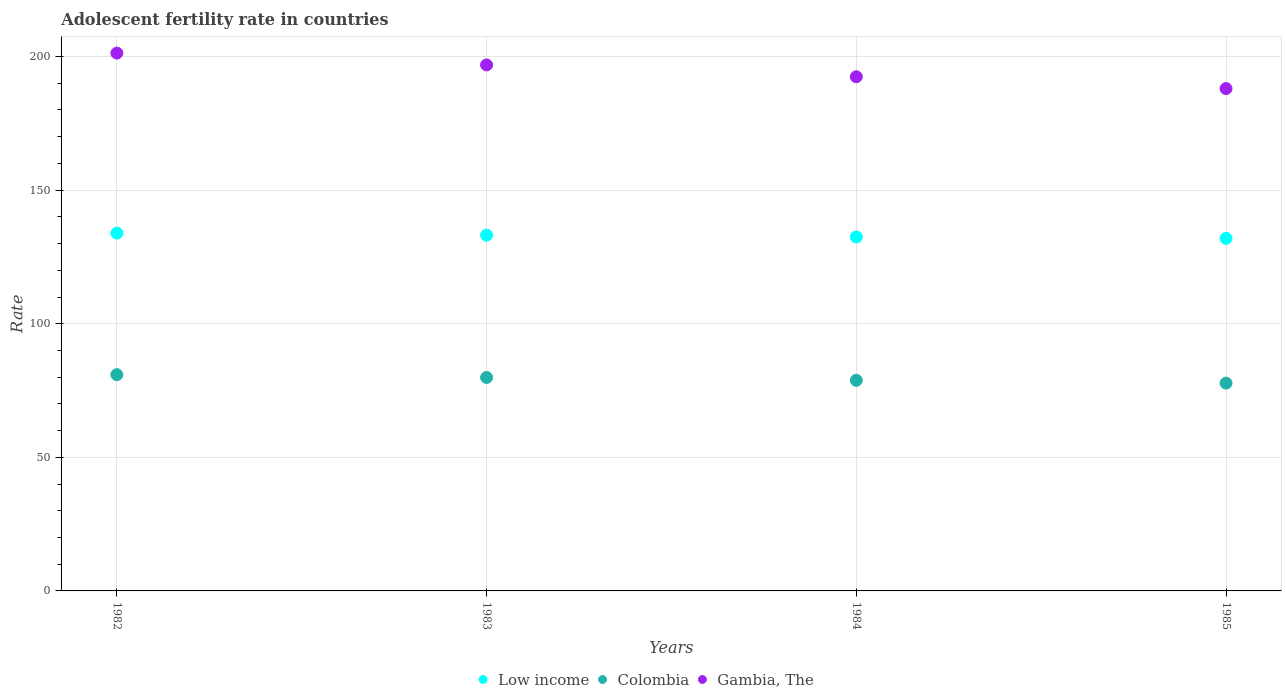How many different coloured dotlines are there?
Your response must be concise. 3. What is the adolescent fertility rate in Low income in 1985?
Offer a terse response. 131.98. Across all years, what is the maximum adolescent fertility rate in Gambia, The?
Provide a succinct answer. 201.3. Across all years, what is the minimum adolescent fertility rate in Gambia, The?
Keep it short and to the point. 188.01. In which year was the adolescent fertility rate in Low income minimum?
Make the answer very short. 1985. What is the total adolescent fertility rate in Gambia, The in the graph?
Provide a succinct answer. 778.62. What is the difference between the adolescent fertility rate in Colombia in 1982 and that in 1983?
Offer a very short reply. 1.06. What is the difference between the adolescent fertility rate in Colombia in 1985 and the adolescent fertility rate in Gambia, The in 1984?
Provide a short and direct response. -114.67. What is the average adolescent fertility rate in Low income per year?
Provide a succinct answer. 132.87. In the year 1984, what is the difference between the adolescent fertility rate in Low income and adolescent fertility rate in Gambia, The?
Offer a very short reply. -59.98. In how many years, is the adolescent fertility rate in Gambia, The greater than 150?
Your response must be concise. 4. What is the ratio of the adolescent fertility rate in Colombia in 1983 to that in 1985?
Ensure brevity in your answer.  1.03. Is the adolescent fertility rate in Low income in 1982 less than that in 1984?
Provide a succinct answer. No. Is the difference between the adolescent fertility rate in Low income in 1983 and 1985 greater than the difference between the adolescent fertility rate in Gambia, The in 1983 and 1985?
Give a very brief answer. No. What is the difference between the highest and the second highest adolescent fertility rate in Colombia?
Offer a terse response. 1.06. What is the difference between the highest and the lowest adolescent fertility rate in Colombia?
Offer a very short reply. 3.17. In how many years, is the adolescent fertility rate in Low income greater than the average adolescent fertility rate in Low income taken over all years?
Your answer should be compact. 2. Is it the case that in every year, the sum of the adolescent fertility rate in Gambia, The and adolescent fertility rate in Low income  is greater than the adolescent fertility rate in Colombia?
Provide a succinct answer. Yes. Does the adolescent fertility rate in Low income monotonically increase over the years?
Provide a short and direct response. No. Is the adolescent fertility rate in Colombia strictly greater than the adolescent fertility rate in Low income over the years?
Offer a terse response. No. How many dotlines are there?
Offer a terse response. 3. What is the difference between two consecutive major ticks on the Y-axis?
Offer a terse response. 50. Does the graph contain any zero values?
Ensure brevity in your answer.  No. Does the graph contain grids?
Give a very brief answer. Yes. Where does the legend appear in the graph?
Ensure brevity in your answer.  Bottom center. How many legend labels are there?
Your answer should be very brief. 3. How are the legend labels stacked?
Your answer should be very brief. Horizontal. What is the title of the graph?
Keep it short and to the point. Adolescent fertility rate in countries. Does "Northern Mariana Islands" appear as one of the legend labels in the graph?
Your answer should be compact. No. What is the label or title of the Y-axis?
Your answer should be very brief. Rate. What is the Rate in Low income in 1982?
Your answer should be compact. 133.92. What is the Rate in Colombia in 1982?
Make the answer very short. 80.94. What is the Rate in Gambia, The in 1982?
Provide a succinct answer. 201.3. What is the Rate in Low income in 1983?
Offer a terse response. 133.14. What is the Rate of Colombia in 1983?
Provide a succinct answer. 79.88. What is the Rate in Gambia, The in 1983?
Give a very brief answer. 196.87. What is the Rate in Low income in 1984?
Your answer should be very brief. 132.46. What is the Rate of Colombia in 1984?
Give a very brief answer. 78.83. What is the Rate in Gambia, The in 1984?
Your answer should be compact. 192.44. What is the Rate of Low income in 1985?
Your answer should be very brief. 131.98. What is the Rate of Colombia in 1985?
Offer a terse response. 77.77. What is the Rate in Gambia, The in 1985?
Your answer should be compact. 188.01. Across all years, what is the maximum Rate of Low income?
Provide a succinct answer. 133.92. Across all years, what is the maximum Rate of Colombia?
Offer a very short reply. 80.94. Across all years, what is the maximum Rate of Gambia, The?
Give a very brief answer. 201.3. Across all years, what is the minimum Rate in Low income?
Make the answer very short. 131.98. Across all years, what is the minimum Rate in Colombia?
Provide a succinct answer. 77.77. Across all years, what is the minimum Rate of Gambia, The?
Make the answer very short. 188.01. What is the total Rate in Low income in the graph?
Give a very brief answer. 531.5. What is the total Rate of Colombia in the graph?
Your answer should be very brief. 317.42. What is the total Rate in Gambia, The in the graph?
Ensure brevity in your answer.  778.62. What is the difference between the Rate in Low income in 1982 and that in 1983?
Your response must be concise. 0.77. What is the difference between the Rate in Colombia in 1982 and that in 1983?
Give a very brief answer. 1.06. What is the difference between the Rate of Gambia, The in 1982 and that in 1983?
Provide a short and direct response. 4.43. What is the difference between the Rate in Low income in 1982 and that in 1984?
Your answer should be very brief. 1.46. What is the difference between the Rate of Colombia in 1982 and that in 1984?
Your answer should be compact. 2.11. What is the difference between the Rate in Gambia, The in 1982 and that in 1984?
Offer a terse response. 8.86. What is the difference between the Rate in Low income in 1982 and that in 1985?
Ensure brevity in your answer.  1.94. What is the difference between the Rate in Colombia in 1982 and that in 1985?
Your answer should be very brief. 3.17. What is the difference between the Rate in Gambia, The in 1982 and that in 1985?
Provide a short and direct response. 13.29. What is the difference between the Rate in Low income in 1983 and that in 1984?
Give a very brief answer. 0.68. What is the difference between the Rate of Colombia in 1983 and that in 1984?
Keep it short and to the point. 1.06. What is the difference between the Rate in Gambia, The in 1983 and that in 1984?
Offer a very short reply. 4.43. What is the difference between the Rate of Low income in 1983 and that in 1985?
Give a very brief answer. 1.17. What is the difference between the Rate in Colombia in 1983 and that in 1985?
Your answer should be compact. 2.11. What is the difference between the Rate of Gambia, The in 1983 and that in 1985?
Provide a short and direct response. 8.86. What is the difference between the Rate in Low income in 1984 and that in 1985?
Give a very brief answer. 0.49. What is the difference between the Rate of Colombia in 1984 and that in 1985?
Keep it short and to the point. 1.06. What is the difference between the Rate of Gambia, The in 1984 and that in 1985?
Give a very brief answer. 4.43. What is the difference between the Rate of Low income in 1982 and the Rate of Colombia in 1983?
Provide a short and direct response. 54.03. What is the difference between the Rate in Low income in 1982 and the Rate in Gambia, The in 1983?
Ensure brevity in your answer.  -62.95. What is the difference between the Rate in Colombia in 1982 and the Rate in Gambia, The in 1983?
Offer a terse response. -115.93. What is the difference between the Rate of Low income in 1982 and the Rate of Colombia in 1984?
Make the answer very short. 55.09. What is the difference between the Rate of Low income in 1982 and the Rate of Gambia, The in 1984?
Provide a short and direct response. -58.52. What is the difference between the Rate of Colombia in 1982 and the Rate of Gambia, The in 1984?
Ensure brevity in your answer.  -111.5. What is the difference between the Rate in Low income in 1982 and the Rate in Colombia in 1985?
Keep it short and to the point. 56.15. What is the difference between the Rate of Low income in 1982 and the Rate of Gambia, The in 1985?
Ensure brevity in your answer.  -54.09. What is the difference between the Rate in Colombia in 1982 and the Rate in Gambia, The in 1985?
Provide a short and direct response. -107.07. What is the difference between the Rate of Low income in 1983 and the Rate of Colombia in 1984?
Keep it short and to the point. 54.32. What is the difference between the Rate in Low income in 1983 and the Rate in Gambia, The in 1984?
Make the answer very short. -59.3. What is the difference between the Rate of Colombia in 1983 and the Rate of Gambia, The in 1984?
Keep it short and to the point. -112.56. What is the difference between the Rate in Low income in 1983 and the Rate in Colombia in 1985?
Give a very brief answer. 55.37. What is the difference between the Rate of Low income in 1983 and the Rate of Gambia, The in 1985?
Ensure brevity in your answer.  -54.87. What is the difference between the Rate in Colombia in 1983 and the Rate in Gambia, The in 1985?
Keep it short and to the point. -108.13. What is the difference between the Rate in Low income in 1984 and the Rate in Colombia in 1985?
Provide a short and direct response. 54.69. What is the difference between the Rate of Low income in 1984 and the Rate of Gambia, The in 1985?
Your answer should be very brief. -55.55. What is the difference between the Rate of Colombia in 1984 and the Rate of Gambia, The in 1985?
Your answer should be compact. -109.18. What is the average Rate of Low income per year?
Make the answer very short. 132.87. What is the average Rate in Colombia per year?
Provide a succinct answer. 79.36. What is the average Rate in Gambia, The per year?
Provide a succinct answer. 194.66. In the year 1982, what is the difference between the Rate of Low income and Rate of Colombia?
Make the answer very short. 52.98. In the year 1982, what is the difference between the Rate of Low income and Rate of Gambia, The?
Ensure brevity in your answer.  -67.38. In the year 1982, what is the difference between the Rate in Colombia and Rate in Gambia, The?
Your answer should be very brief. -120.36. In the year 1983, what is the difference between the Rate in Low income and Rate in Colombia?
Give a very brief answer. 53.26. In the year 1983, what is the difference between the Rate of Low income and Rate of Gambia, The?
Your answer should be very brief. -63.73. In the year 1983, what is the difference between the Rate of Colombia and Rate of Gambia, The?
Your response must be concise. -116.99. In the year 1984, what is the difference between the Rate in Low income and Rate in Colombia?
Offer a terse response. 53.63. In the year 1984, what is the difference between the Rate of Low income and Rate of Gambia, The?
Keep it short and to the point. -59.98. In the year 1984, what is the difference between the Rate in Colombia and Rate in Gambia, The?
Keep it short and to the point. -113.61. In the year 1985, what is the difference between the Rate in Low income and Rate in Colombia?
Give a very brief answer. 54.2. In the year 1985, what is the difference between the Rate of Low income and Rate of Gambia, The?
Give a very brief answer. -56.04. In the year 1985, what is the difference between the Rate of Colombia and Rate of Gambia, The?
Your response must be concise. -110.24. What is the ratio of the Rate of Low income in 1982 to that in 1983?
Your answer should be compact. 1.01. What is the ratio of the Rate in Colombia in 1982 to that in 1983?
Your answer should be very brief. 1.01. What is the ratio of the Rate of Gambia, The in 1982 to that in 1983?
Your answer should be very brief. 1.02. What is the ratio of the Rate of Colombia in 1982 to that in 1984?
Offer a very short reply. 1.03. What is the ratio of the Rate of Gambia, The in 1982 to that in 1984?
Your answer should be very brief. 1.05. What is the ratio of the Rate in Low income in 1982 to that in 1985?
Keep it short and to the point. 1.01. What is the ratio of the Rate in Colombia in 1982 to that in 1985?
Offer a very short reply. 1.04. What is the ratio of the Rate of Gambia, The in 1982 to that in 1985?
Keep it short and to the point. 1.07. What is the ratio of the Rate of Low income in 1983 to that in 1984?
Keep it short and to the point. 1.01. What is the ratio of the Rate of Colombia in 1983 to that in 1984?
Give a very brief answer. 1.01. What is the ratio of the Rate of Gambia, The in 1983 to that in 1984?
Provide a succinct answer. 1.02. What is the ratio of the Rate of Low income in 1983 to that in 1985?
Your response must be concise. 1.01. What is the ratio of the Rate in Colombia in 1983 to that in 1985?
Provide a succinct answer. 1.03. What is the ratio of the Rate in Gambia, The in 1983 to that in 1985?
Your answer should be compact. 1.05. What is the ratio of the Rate of Colombia in 1984 to that in 1985?
Ensure brevity in your answer.  1.01. What is the ratio of the Rate in Gambia, The in 1984 to that in 1985?
Your answer should be compact. 1.02. What is the difference between the highest and the second highest Rate of Low income?
Make the answer very short. 0.77. What is the difference between the highest and the second highest Rate in Colombia?
Your response must be concise. 1.06. What is the difference between the highest and the second highest Rate in Gambia, The?
Offer a terse response. 4.43. What is the difference between the highest and the lowest Rate of Low income?
Offer a very short reply. 1.94. What is the difference between the highest and the lowest Rate in Colombia?
Give a very brief answer. 3.17. What is the difference between the highest and the lowest Rate of Gambia, The?
Keep it short and to the point. 13.29. 